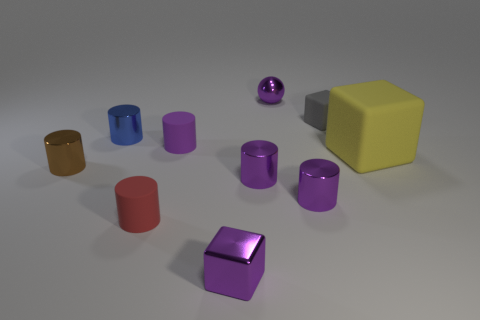How many tiny purple metal balls are there?
Your answer should be very brief. 1. What is the shape of the purple object that is both on the left side of the tiny metal ball and on the right side of the purple block?
Your answer should be compact. Cylinder. There is a small metallic cylinder left of the blue metallic thing; is it the same color as the block in front of the yellow matte cube?
Make the answer very short. No. There is a rubber cylinder that is the same color as the shiny block; what is its size?
Provide a short and direct response. Small. Are there any other big blocks that have the same material as the big block?
Provide a short and direct response. No. Are there the same number of metal balls in front of the large thing and tiny purple metal blocks to the right of the tiny metallic ball?
Ensure brevity in your answer.  Yes. There is a matte cylinder behind the big object; what is its size?
Provide a succinct answer. Small. What is the tiny block behind the shiny cylinder that is behind the brown metal cylinder made of?
Offer a very short reply. Rubber. There is a small block right of the metallic ball that is on the right side of the brown shiny thing; how many small things are in front of it?
Your answer should be very brief. 7. Is the thing left of the blue metallic cylinder made of the same material as the cube behind the small blue cylinder?
Your response must be concise. No. 